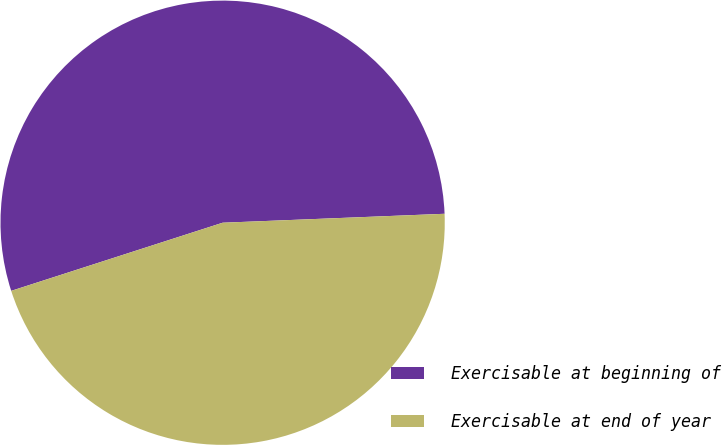Convert chart. <chart><loc_0><loc_0><loc_500><loc_500><pie_chart><fcel>Exercisable at beginning of<fcel>Exercisable at end of year<nl><fcel>54.32%<fcel>45.68%<nl></chart> 